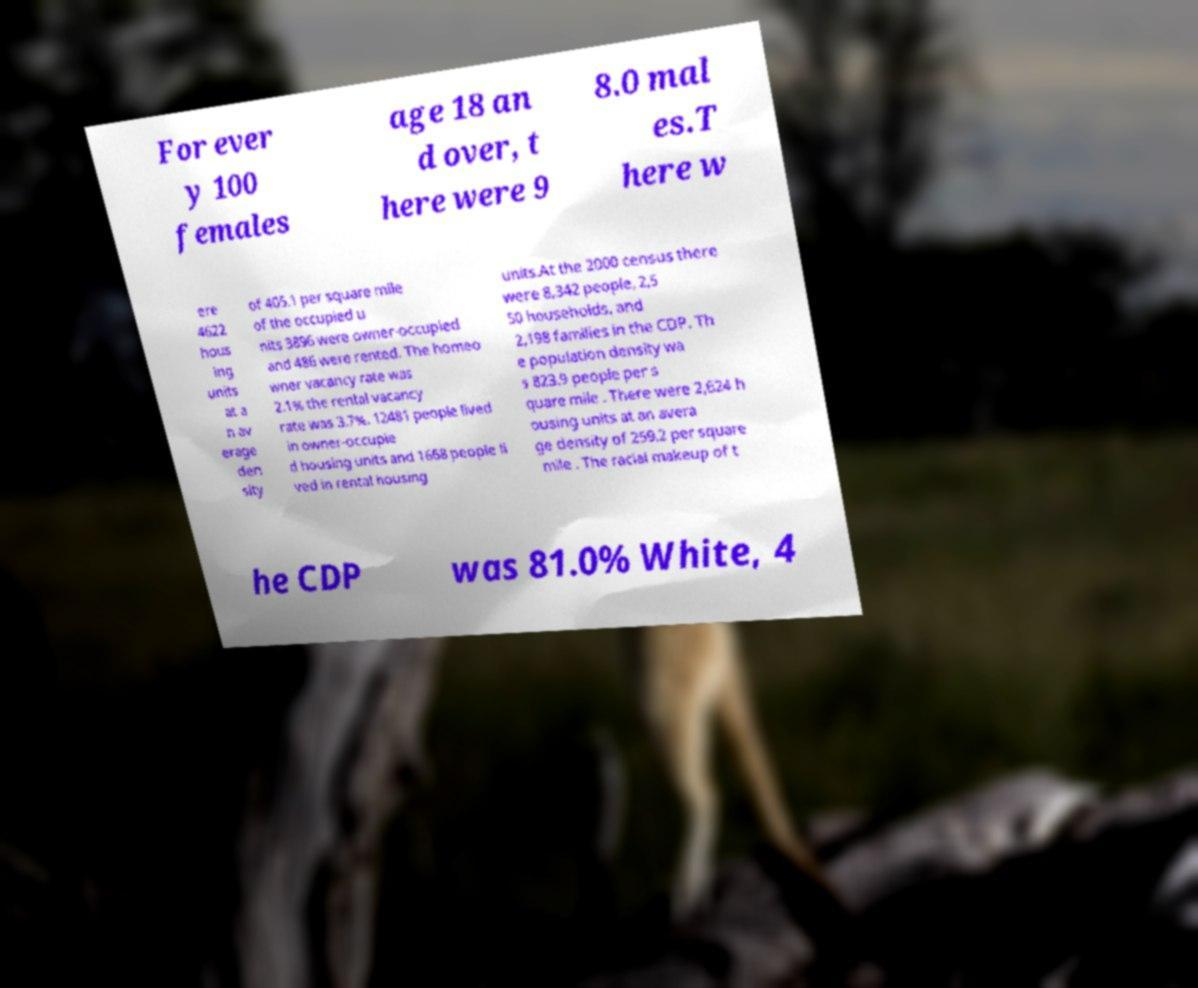Could you assist in decoding the text presented in this image and type it out clearly? For ever y 100 females age 18 an d over, t here were 9 8.0 mal es.T here w ere 4622 hous ing units at a n av erage den sity of 405.1 per square mile of the occupied u nits 3896 were owner-occupied and 486 were rented. The homeo wner vacancy rate was 2.1% the rental vacancy rate was 3.7%. 12481 people lived in owner-occupie d housing units and 1668 people li ved in rental housing units.At the 2000 census there were 8,342 people, 2,5 50 households, and 2,198 families in the CDP. Th e population density wa s 823.9 people per s quare mile . There were 2,624 h ousing units at an avera ge density of 259.2 per square mile . The racial makeup of t he CDP was 81.0% White, 4 